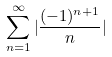<formula> <loc_0><loc_0><loc_500><loc_500>\sum _ { n = 1 } ^ { \infty } | \frac { ( - 1 ) ^ { n + 1 } } { n } |</formula> 